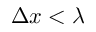<formula> <loc_0><loc_0><loc_500><loc_500>\Delta x < \lambda</formula> 